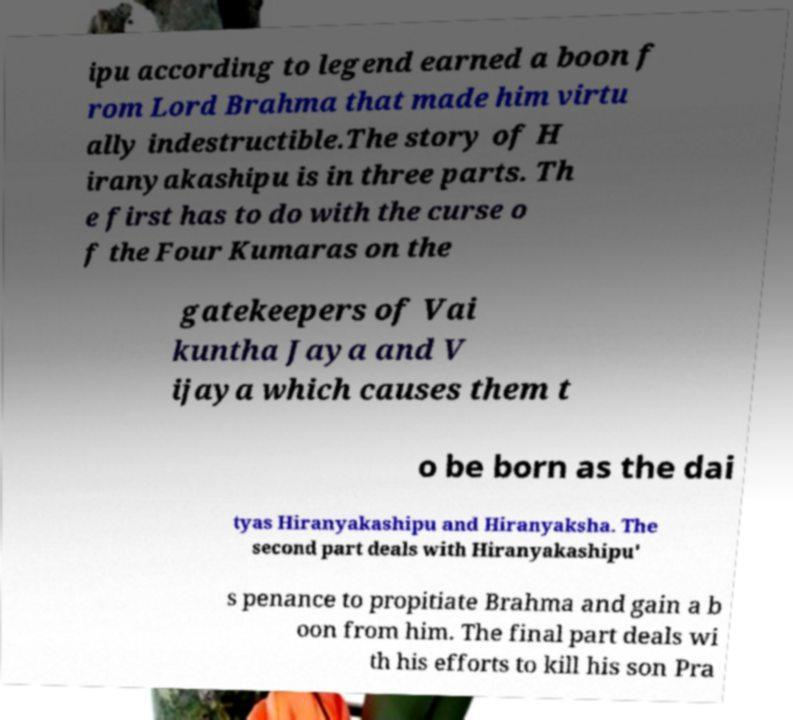There's text embedded in this image that I need extracted. Can you transcribe it verbatim? ipu according to legend earned a boon f rom Lord Brahma that made him virtu ally indestructible.The story of H iranyakashipu is in three parts. Th e first has to do with the curse o f the Four Kumaras on the gatekeepers of Vai kuntha Jaya and V ijaya which causes them t o be born as the dai tyas Hiranyakashipu and Hiranyaksha. The second part deals with Hiranyakashipu' s penance to propitiate Brahma and gain a b oon from him. The final part deals wi th his efforts to kill his son Pra 